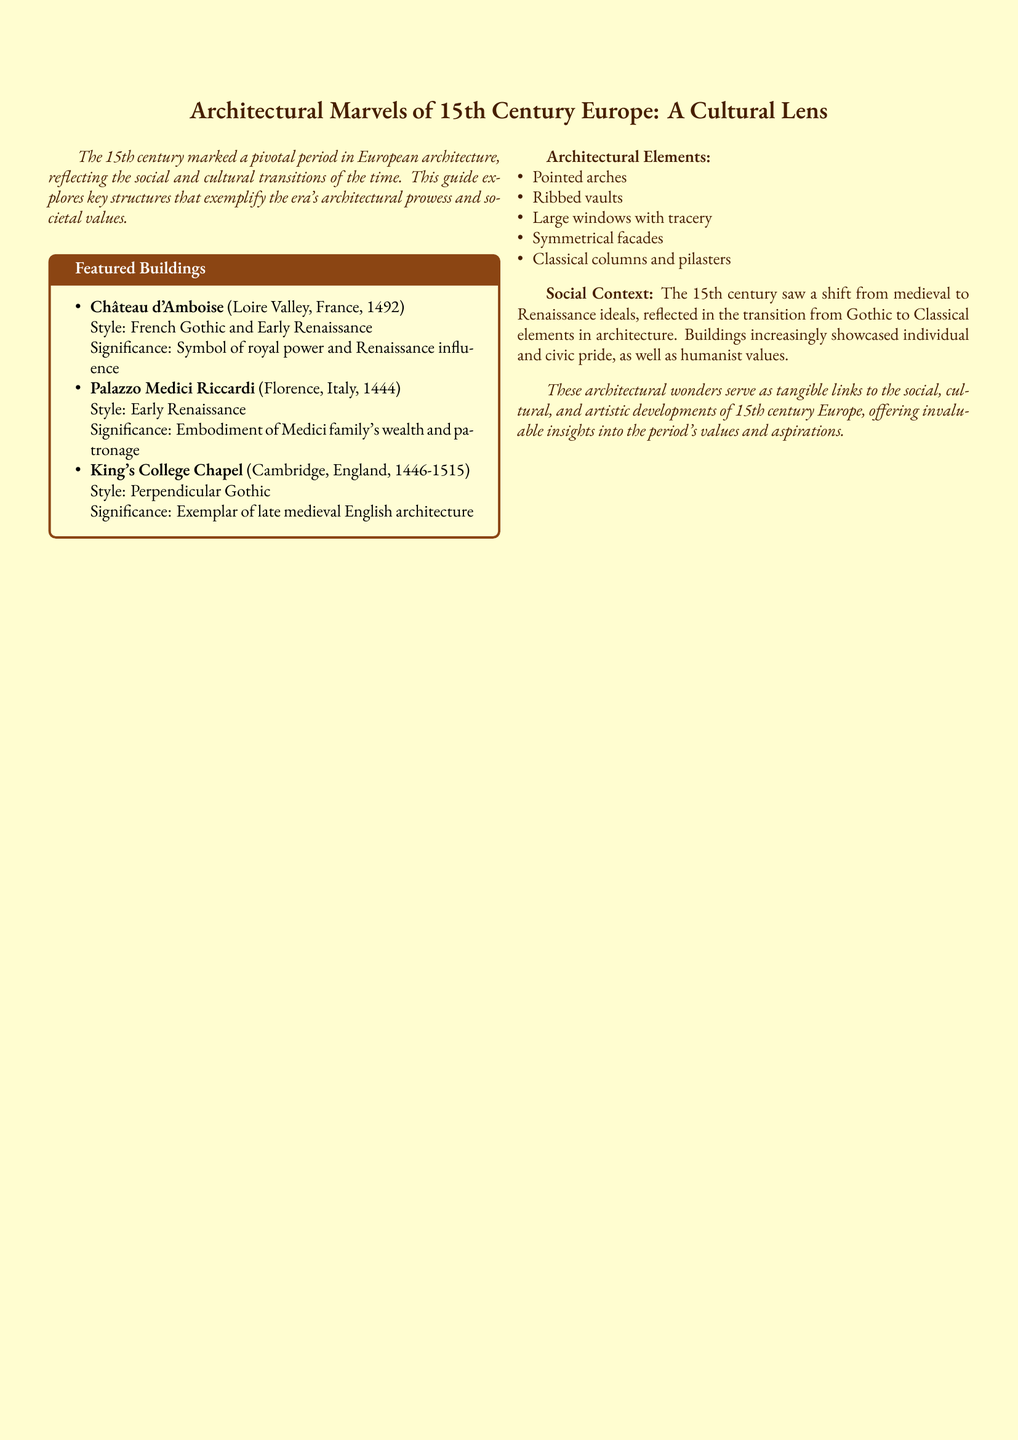What year was Château d'Amboise completed? The document states that Château d'Amboise was completed in 1492.
Answer: 1492 What architectural style is Palazzo Medici Riccardi? The document specifies that Palazzo Medici Riccardi is in the Early Renaissance style.
Answer: Early Renaissance Which building exemplifies late medieval English architecture? The guide highlights King's College Chapel as an exemplar of late medieval English architecture.
Answer: King's College Chapel What architectural element features large windows with tracery? The document lists large windows with tracery as one of the key architectural elements of the 15th century.
Answer: Large windows with tracery What shift in ideals does the 15th century represent? The document indicates a shift from medieval to Renaissance ideals during the 15th century.
Answer: Medieval to Renaissance How many featured buildings are listed in the document? The guide features three prominent buildings.
Answer: Three What geographic location is associated with the Château d'Amboise? The document notes that Château d'Amboise is located in the Loire Valley, France.
Answer: Loire Valley, France What does the King's College Chapel symbolize? The document states that King's College Chapel exemplifies late medieval English architecture.
Answer: Late medieval English architecture 